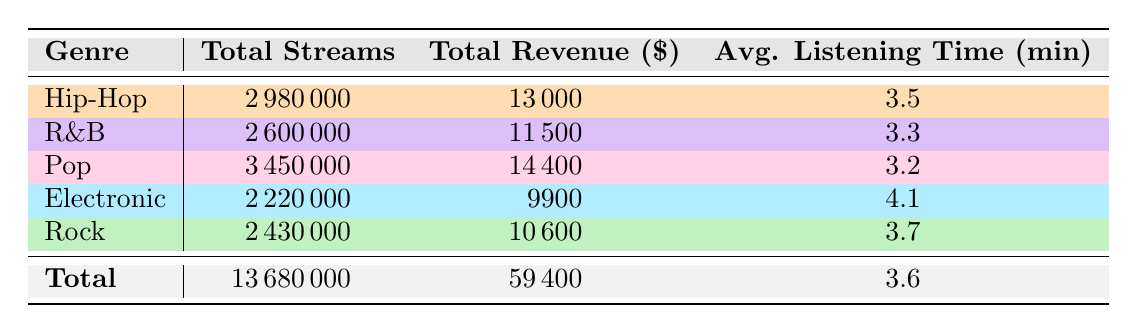What genre has the highest total streams? By examining the "Total Streams" column, Hip-Hop has the highest value of 2,980,000 streams compared to other genres.
Answer: Hip-Hop What is the total revenue for Pop music? The table shows that the total revenue for Pop is $14,400.
Answer: 14400 Which genre has the lowest average listening time? The "Avg. Listening Time" column shows that Pop has the lowest average listening time of 3.2 minutes.
Answer: Pop How many more streams does Hip-Hop have than R&B? The total streams for Hip-Hop is 2,980,000 and for R&B is 2,600,000. The difference is calculated as 2,980,000 - 2,600,000 = 380,000 streams more.
Answer: 380000 Is the total revenue for Electronic music greater than that for Rock? Electronic music revenue is $9,900 and Rock is $10,600. Since $9,900 is less than $10,600, the statement is false.
Answer: No What is the average listening time across all genres? To find the average, we take the sum of all average listening times (3.5 + 3.3 + 3.2 + 4.1 + 3.7 = 17.8) and divide by the number of genres (5). This results in an average listening time of 17.8 / 5 = 3.56 minutes.
Answer: 3.56 Which genre generated the most revenue? Looking into the "Total Revenue" column, Pop has the highest revenue of $14,400, making it the most revenue-generating genre.
Answer: Pop What is the total number of streams across all genres? The total number of streams is the sum of total streams for all genres: 2,980,000 + 2,600,000 + 3,450,000 + 2,220,000 + 2,430,000 = 13,680,000.
Answer: 13680000 Which genre has an average listening time above 4 minutes? By checking the "Avg. Listening Time" column, we see that Electronic music has an average listening time of 4.1 minutes, which is above 4 minutes.
Answer: Yes 